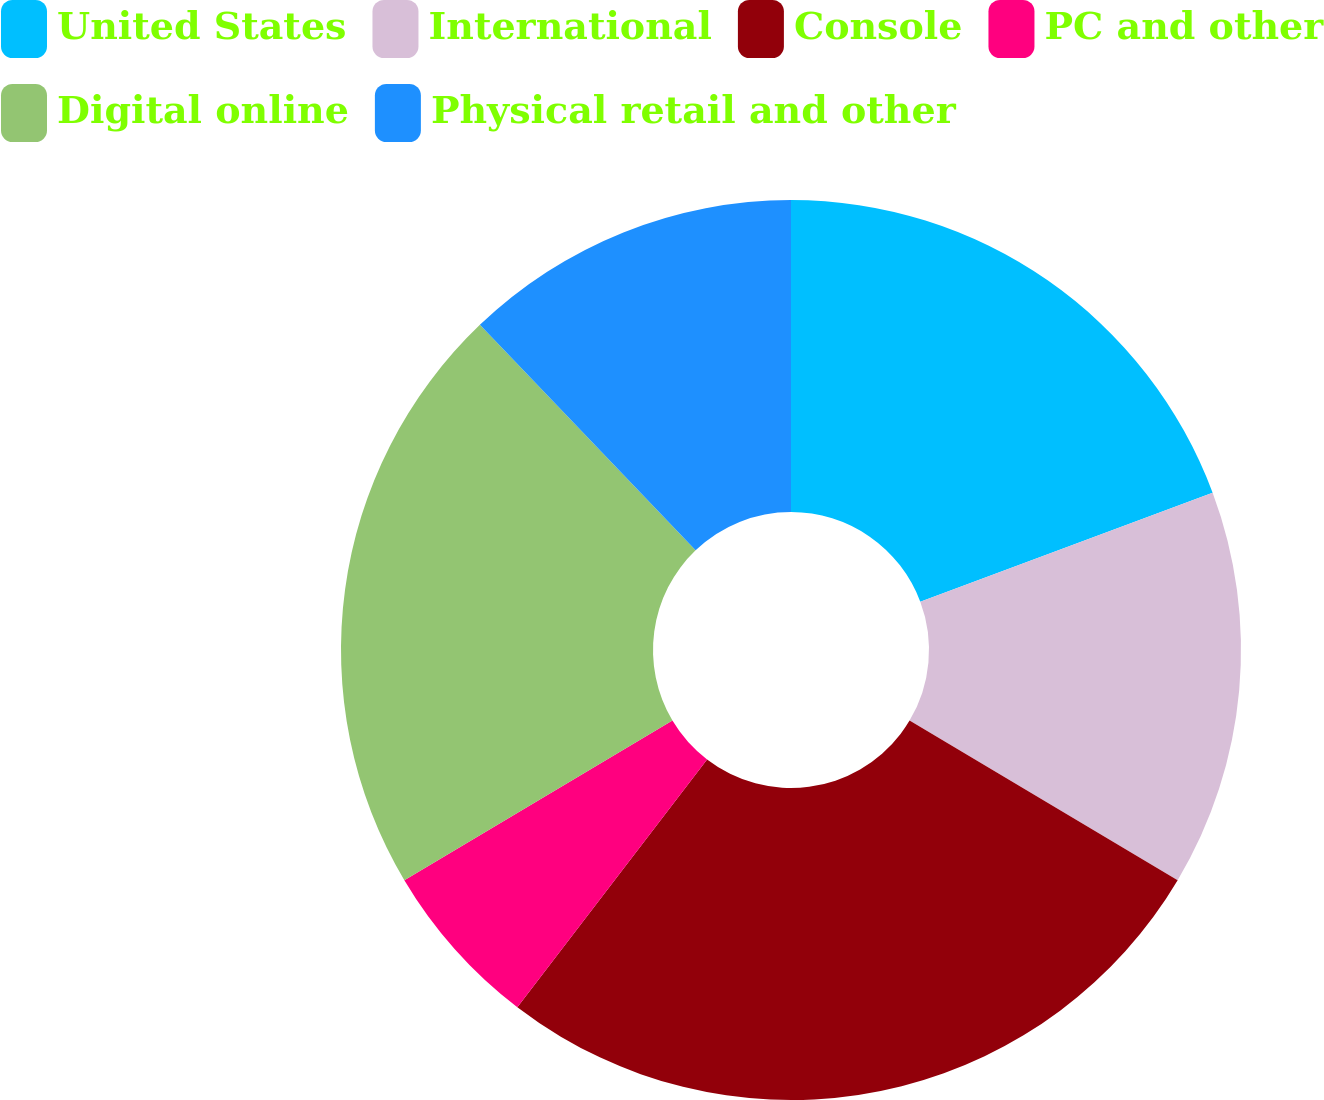Convert chart. <chart><loc_0><loc_0><loc_500><loc_500><pie_chart><fcel>United States<fcel>International<fcel>Console<fcel>PC and other<fcel>Digital online<fcel>Physical retail and other<nl><fcel>19.32%<fcel>14.23%<fcel>26.86%<fcel>6.05%<fcel>21.4%<fcel>12.15%<nl></chart> 